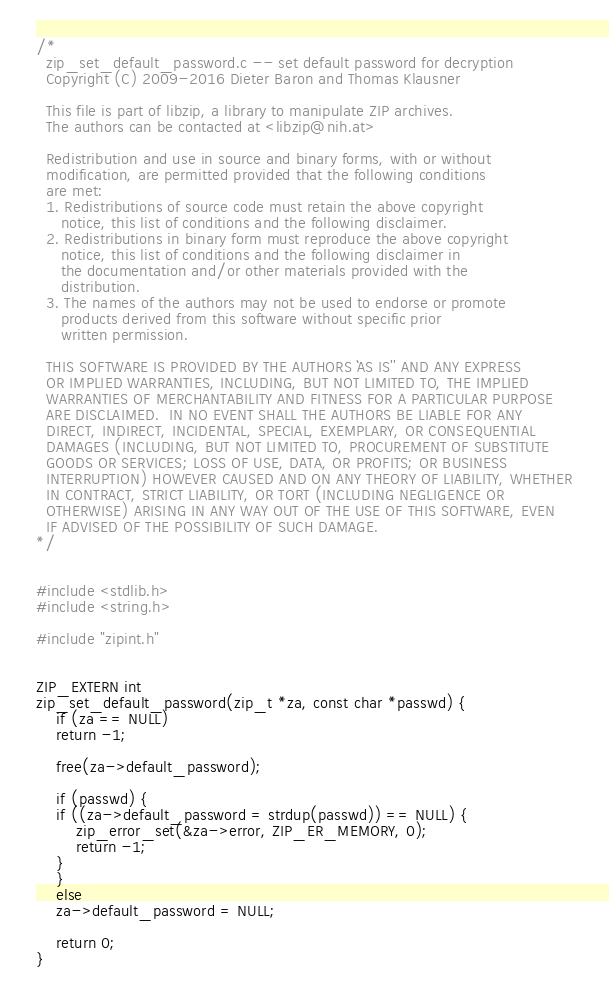Convert code to text. <code><loc_0><loc_0><loc_500><loc_500><_C_>/*
  zip_set_default_password.c -- set default password for decryption
  Copyright (C) 2009-2016 Dieter Baron and Thomas Klausner

  This file is part of libzip, a library to manipulate ZIP archives.
  The authors can be contacted at <libzip@nih.at>

  Redistribution and use in source and binary forms, with or without
  modification, are permitted provided that the following conditions
  are met:
  1. Redistributions of source code must retain the above copyright
     notice, this list of conditions and the following disclaimer.
  2. Redistributions in binary form must reproduce the above copyright
     notice, this list of conditions and the following disclaimer in
     the documentation and/or other materials provided with the
     distribution.
  3. The names of the authors may not be used to endorse or promote
     products derived from this software without specific prior
     written permission.

  THIS SOFTWARE IS PROVIDED BY THE AUTHORS ``AS IS'' AND ANY EXPRESS
  OR IMPLIED WARRANTIES, INCLUDING, BUT NOT LIMITED TO, THE IMPLIED
  WARRANTIES OF MERCHANTABILITY AND FITNESS FOR A PARTICULAR PURPOSE
  ARE DISCLAIMED.  IN NO EVENT SHALL THE AUTHORS BE LIABLE FOR ANY
  DIRECT, INDIRECT, INCIDENTAL, SPECIAL, EXEMPLARY, OR CONSEQUENTIAL
  DAMAGES (INCLUDING, BUT NOT LIMITED TO, PROCUREMENT OF SUBSTITUTE
  GOODS OR SERVICES; LOSS OF USE, DATA, OR PROFITS; OR BUSINESS
  INTERRUPTION) HOWEVER CAUSED AND ON ANY THEORY OF LIABILITY, WHETHER
  IN CONTRACT, STRICT LIABILITY, OR TORT (INCLUDING NEGLIGENCE OR
  OTHERWISE) ARISING IN ANY WAY OUT OF THE USE OF THIS SOFTWARE, EVEN
  IF ADVISED OF THE POSSIBILITY OF SUCH DAMAGE.
*/


#include <stdlib.h>
#include <string.h>

#include "zipint.h"


ZIP_EXTERN int
zip_set_default_password(zip_t *za, const char *passwd) {
    if (za == NULL)
	return -1;

    free(za->default_password);

    if (passwd) {
	if ((za->default_password = strdup(passwd)) == NULL) {
	    zip_error_set(&za->error, ZIP_ER_MEMORY, 0);
	    return -1;
	}
    }
    else
	za->default_password = NULL;

    return 0;
}
</code> 